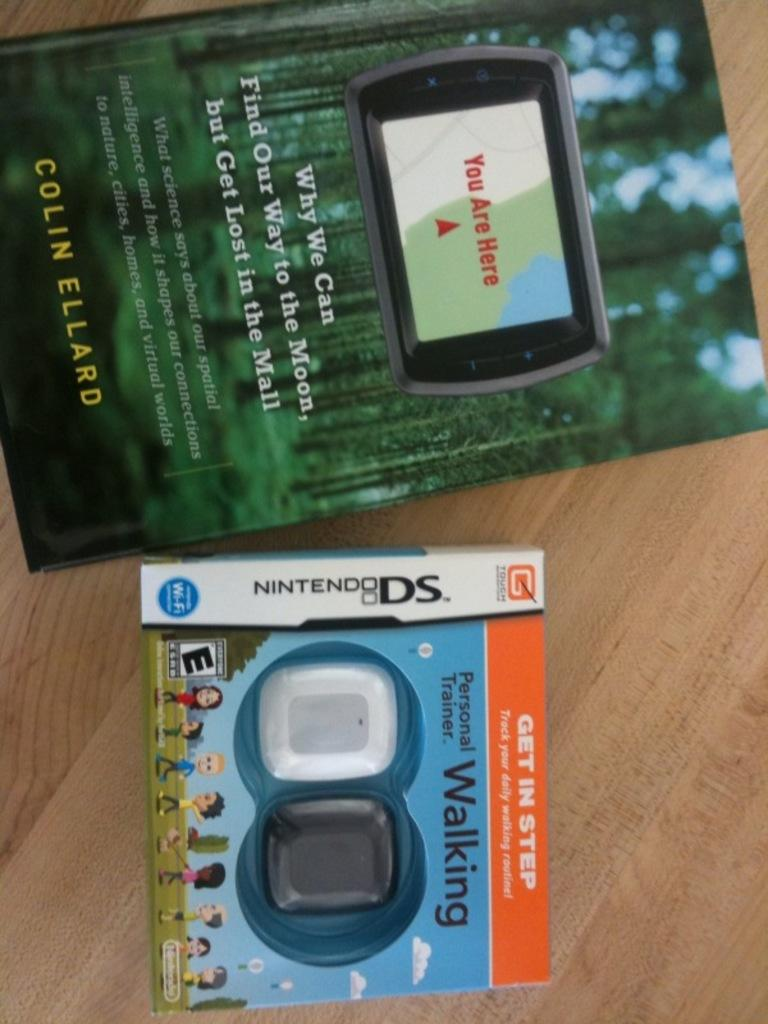Provide a one-sentence caption for the provided image. A book titled Why We Can Find Our Way to the Moon but Get Lost in the Mall laying next to a Nintendo DS,. 